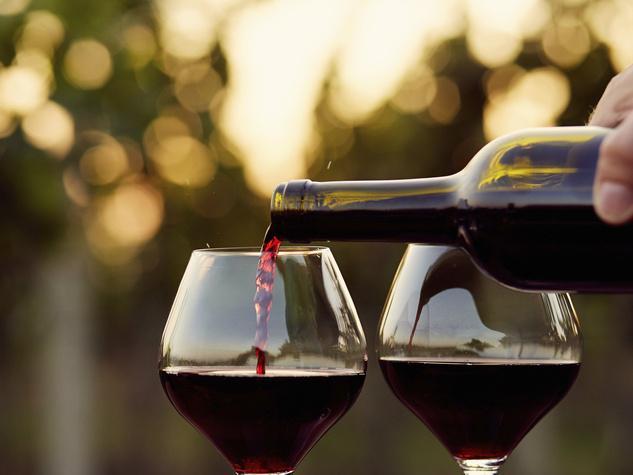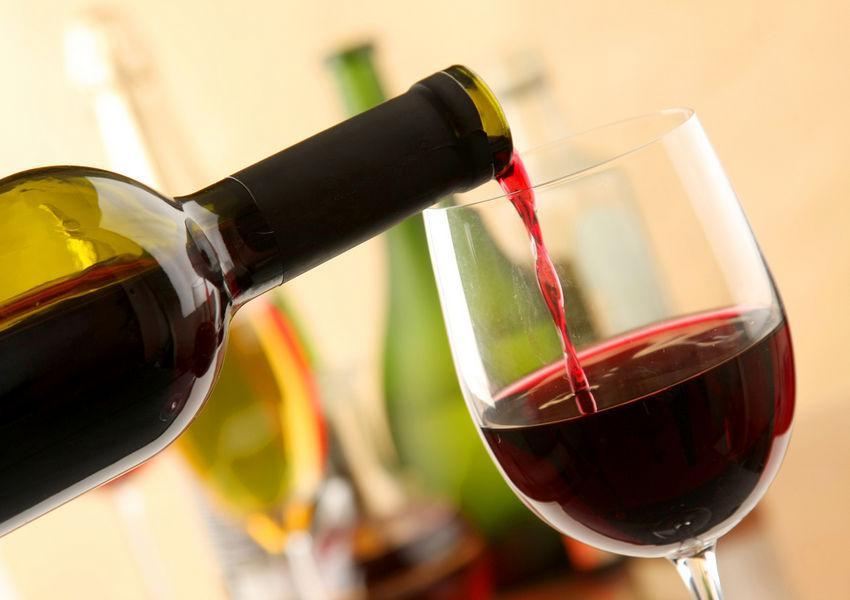The first image is the image on the left, the second image is the image on the right. For the images shown, is this caption "At least one image shows a bunch of grapes near a glass partly filled with red wine." true? Answer yes or no. No. The first image is the image on the left, the second image is the image on the right. Assess this claim about the two images: "In one of the images there are two wine glasses next to at least one bottle of wine and a bunch of grapes.". Correct or not? Answer yes or no. No. 